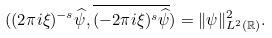<formula> <loc_0><loc_0><loc_500><loc_500>( ( 2 \pi i \xi ) ^ { - s } \widehat { \psi } , \overline { ( - 2 \pi i \xi ) ^ { s } \widehat { \psi } } ) = \| \psi \| ^ { 2 } _ { L ^ { 2 } ( \mathbb { R } ) } .</formula> 